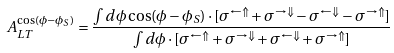<formula> <loc_0><loc_0><loc_500><loc_500>A ^ { \cos ( \phi - \phi _ { S } ) } _ { L T } = \frac { \int d \phi \cos ( \phi - \phi _ { S } ) \cdot [ \sigma ^ { \leftarrow \Uparrow } + \sigma ^ { \rightarrow \Downarrow } - \sigma ^ { \leftarrow \Downarrow } - \sigma ^ { \rightarrow \Uparrow } ] } { \int d \phi \cdot [ \sigma ^ { \leftarrow \Uparrow } + \sigma ^ { \rightarrow \Downarrow } + \sigma ^ { \leftarrow \Downarrow } + \sigma ^ { \rightarrow \Uparrow } ] }</formula> 